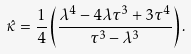<formula> <loc_0><loc_0><loc_500><loc_500>\hat { \kappa } = \frac { 1 } { 4 } \left ( \frac { \lambda ^ { 4 } - 4 \lambda \tau ^ { 3 } + 3 \tau ^ { 4 } } { \tau ^ { 3 } - \lambda ^ { 3 } } \right ) .</formula> 